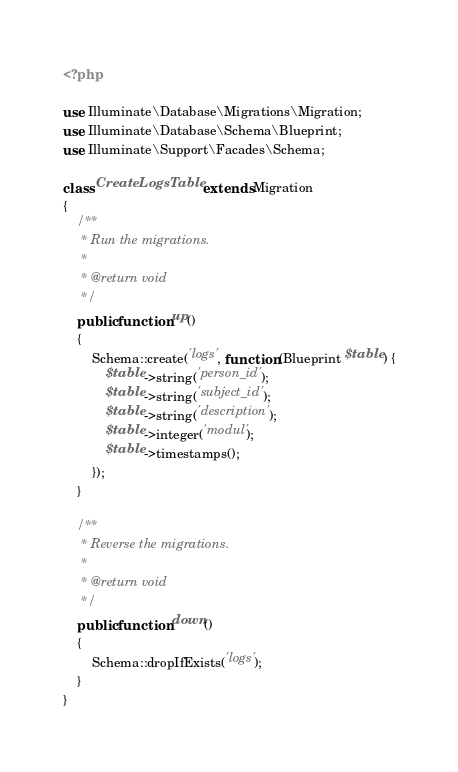<code> <loc_0><loc_0><loc_500><loc_500><_PHP_><?php

use Illuminate\Database\Migrations\Migration;
use Illuminate\Database\Schema\Blueprint;
use Illuminate\Support\Facades\Schema;

class CreateLogsTable extends Migration
{
    /**
     * Run the migrations.
     *
     * @return void
     */
    public function up()
    {
        Schema::create('logs', function (Blueprint $table) {
            $table->string('person_id');
            $table->string('subject_id');
            $table->string('description');
            $table->integer('modul');
            $table->timestamps();
        });
    }

    /**
     * Reverse the migrations.
     *
     * @return void
     */
    public function down()
    {
        Schema::dropIfExists('logs');
    }
}
</code> 